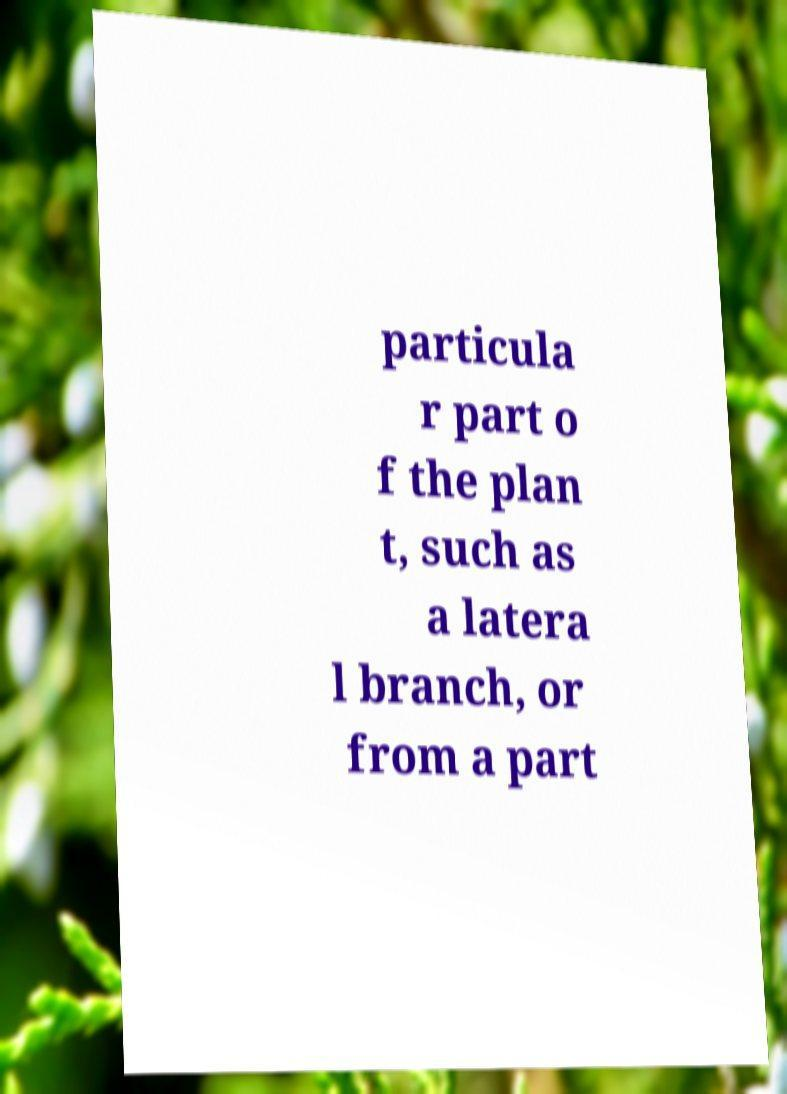I need the written content from this picture converted into text. Can you do that? particula r part o f the plan t, such as a latera l branch, or from a part 